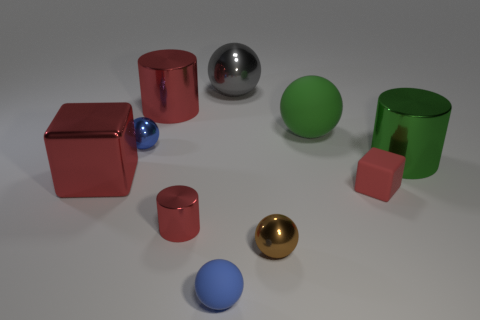There is a gray thing that is the same shape as the tiny brown object; what material is it?
Your response must be concise. Metal. There is another block that is the same color as the small rubber cube; what is its size?
Provide a succinct answer. Large. The small ball left of the tiny red object on the left side of the small brown metallic thing is made of what material?
Offer a terse response. Metal. Are there more big gray objects that are behind the tiny blue matte object than yellow matte cylinders?
Provide a succinct answer. Yes. Is there a red cube made of the same material as the tiny brown ball?
Keep it short and to the point. Yes. There is a red object right of the gray thing; does it have the same shape as the big gray metal object?
Your answer should be compact. No. There is a small rubber thing that is in front of the tiny matte thing right of the big gray metallic object; what number of small objects are in front of it?
Your answer should be very brief. 0. Is the number of small red things that are behind the rubber block less than the number of red rubber blocks that are to the left of the small metal cylinder?
Ensure brevity in your answer.  No. What color is the other big matte object that is the same shape as the gray thing?
Offer a very short reply. Green. How big is the red matte block?
Provide a succinct answer. Small. 